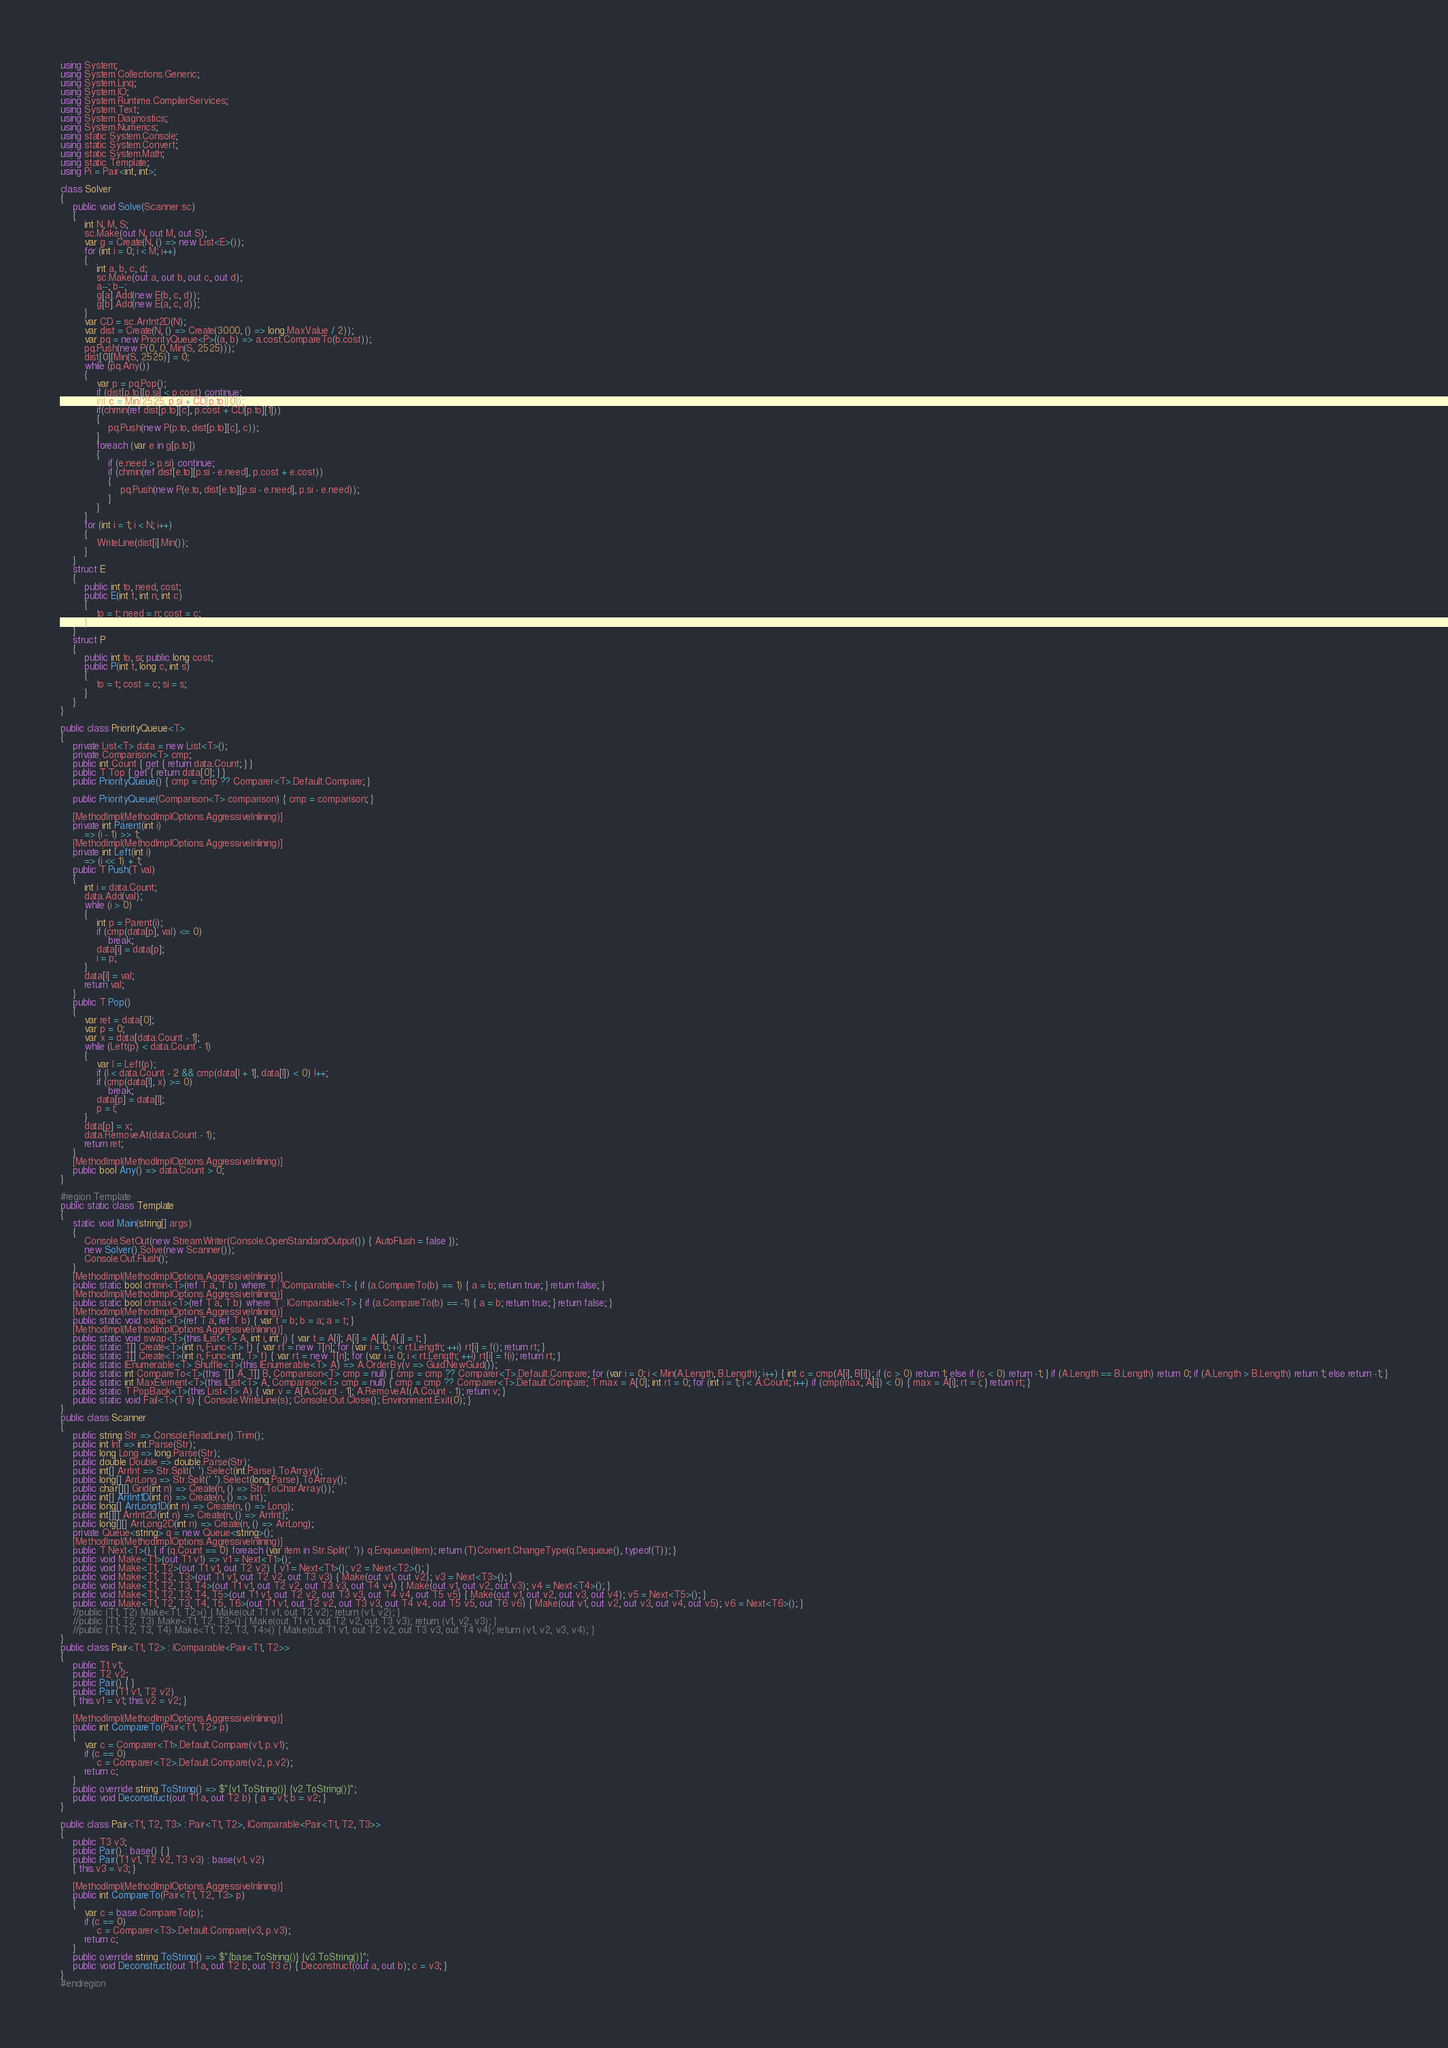<code> <loc_0><loc_0><loc_500><loc_500><_C#_>using System;
using System.Collections.Generic;
using System.Linq;
using System.IO;
using System.Runtime.CompilerServices;
using System.Text;
using System.Diagnostics;
using System.Numerics;
using static System.Console;
using static System.Convert;
using static System.Math;
using static Template;
using Pi = Pair<int, int>;

class Solver
{
    public void Solve(Scanner sc)
    {
        int N, M, S;
        sc.Make(out N, out M, out S);
        var g = Create(N, () => new List<E>());
        for (int i = 0; i < M; i++)
        {
            int a, b, c, d;
            sc.Make(out a, out b, out c, out d);
            a--; b--;
            g[a].Add(new E(b, c, d));
            g[b].Add(new E(a, c, d));
        }
        var CD = sc.ArrInt2D(N);
        var dist = Create(N, () => Create(3000, () => long.MaxValue / 2));
        var pq = new PriorityQueue<P>((a, b) => a.cost.CompareTo(b.cost));
        pq.Push(new P(0, 0, Min(S, 2525)));
        dist[0][Min(S, 2525)] = 0;
        while (pq.Any())
        {
            var p = pq.Pop();
            if (dist[p.to][p.si] < p.cost) continue;
            int c = Min(2525, p.si + CD[p.to][0]);
            if(chmin(ref dist[p.to][c], p.cost + CD[p.to][1]))
            {
                pq.Push(new P(p.to, dist[p.to][c], c));
            }
            foreach (var e in g[p.to])
            {
                if (e.need > p.si) continue;
                if (chmin(ref dist[e.to][p.si - e.need], p.cost + e.cost))
                {
                    pq.Push(new P(e.to, dist[e.to][p.si - e.need], p.si - e.need));
                }
            }
        }
        for (int i = 1; i < N; i++)
        {
            WriteLine(dist[i].Min());
        }
    }
    struct E
    {
        public int to, need, cost;
        public E(int t, int n, int c)
        {
            to = t; need = n; cost = c;
        }
    }
    struct P
    {
        public int to, si; public long cost;
        public P(int t, long c, int s)
        {
            to = t; cost = c; si = s;
        }
    }
}

public class PriorityQueue<T>
{
    private List<T> data = new List<T>();
    private Comparison<T> cmp;
    public int Count { get { return data.Count; } }
    public T Top { get { return data[0]; } }
    public PriorityQueue() { cmp = cmp ?? Comparer<T>.Default.Compare; }

    public PriorityQueue(Comparison<T> comparison) { cmp = comparison; }

    [MethodImpl(MethodImplOptions.AggressiveInlining)]
    private int Parent(int i)
        => (i - 1) >> 1;
    [MethodImpl(MethodImplOptions.AggressiveInlining)]
    private int Left(int i)
        => (i << 1) + 1;
    public T Push(T val)
    {
        int i = data.Count;
        data.Add(val);
        while (i > 0)
        {
            int p = Parent(i);
            if (cmp(data[p], val) <= 0)
                break;
            data[i] = data[p];
            i = p;
        }
        data[i] = val;
        return val;
    }
    public T Pop()
    {
        var ret = data[0];
        var p = 0;
        var x = data[data.Count - 1];
        while (Left(p) < data.Count - 1)
        {
            var l = Left(p);
            if (l < data.Count - 2 && cmp(data[l + 1], data[l]) < 0) l++;
            if (cmp(data[l], x) >= 0)
                break;
            data[p] = data[l];
            p = l;
        }
        data[p] = x;
        data.RemoveAt(data.Count - 1);
        return ret;
    }
    [MethodImpl(MethodImplOptions.AggressiveInlining)]
    public bool Any() => data.Count > 0;
}

#region Template
public static class Template
{
    static void Main(string[] args)
    {
        Console.SetOut(new StreamWriter(Console.OpenStandardOutput()) { AutoFlush = false });
        new Solver().Solve(new Scanner());
        Console.Out.Flush();
    }
    [MethodImpl(MethodImplOptions.AggressiveInlining)]
    public static bool chmin<T>(ref T a, T b) where T : IComparable<T> { if (a.CompareTo(b) == 1) { a = b; return true; } return false; }
    [MethodImpl(MethodImplOptions.AggressiveInlining)]
    public static bool chmax<T>(ref T a, T b) where T : IComparable<T> { if (a.CompareTo(b) == -1) { a = b; return true; } return false; }
    [MethodImpl(MethodImplOptions.AggressiveInlining)]
    public static void swap<T>(ref T a, ref T b) { var t = b; b = a; a = t; }
    [MethodImpl(MethodImplOptions.AggressiveInlining)]
    public static void swap<T>(this IList<T> A, int i, int j) { var t = A[i]; A[i] = A[j]; A[j] = t; }
    public static T[] Create<T>(int n, Func<T> f) { var rt = new T[n]; for (var i = 0; i < rt.Length; ++i) rt[i] = f(); return rt; }
    public static T[] Create<T>(int n, Func<int, T> f) { var rt = new T[n]; for (var i = 0; i < rt.Length; ++i) rt[i] = f(i); return rt; }
    public static IEnumerable<T> Shuffle<T>(this IEnumerable<T> A) => A.OrderBy(v => Guid.NewGuid());
    public static int CompareTo<T>(this T[] A, T[] B, Comparison<T> cmp = null) { cmp = cmp ?? Comparer<T>.Default.Compare; for (var i = 0; i < Min(A.Length, B.Length); i++) { int c = cmp(A[i], B[i]); if (c > 0) return 1; else if (c < 0) return -1; } if (A.Length == B.Length) return 0; if (A.Length > B.Length) return 1; else return -1; }
    public static int MaxElement<T>(this IList<T> A, Comparison<T> cmp = null) { cmp = cmp ?? Comparer<T>.Default.Compare; T max = A[0]; int rt = 0; for (int i = 1; i < A.Count; i++) if (cmp(max, A[i]) < 0) { max = A[i]; rt = i; } return rt; }
    public static T PopBack<T>(this List<T> A) { var v = A[A.Count - 1]; A.RemoveAt(A.Count - 1); return v; }
    public static void Fail<T>(T s) { Console.WriteLine(s); Console.Out.Close(); Environment.Exit(0); }
}
public class Scanner
{
    public string Str => Console.ReadLine().Trim();
    public int Int => int.Parse(Str);
    public long Long => long.Parse(Str);
    public double Double => double.Parse(Str);
    public int[] ArrInt => Str.Split(' ').Select(int.Parse).ToArray();
    public long[] ArrLong => Str.Split(' ').Select(long.Parse).ToArray();
    public char[][] Grid(int n) => Create(n, () => Str.ToCharArray());
    public int[] ArrInt1D(int n) => Create(n, () => Int);
    public long[] ArrLong1D(int n) => Create(n, () => Long);
    public int[][] ArrInt2D(int n) => Create(n, () => ArrInt);
    public long[][] ArrLong2D(int n) => Create(n, () => ArrLong);
    private Queue<string> q = new Queue<string>();
    [MethodImpl(MethodImplOptions.AggressiveInlining)]
    public T Next<T>() { if (q.Count == 0) foreach (var item in Str.Split(' ')) q.Enqueue(item); return (T)Convert.ChangeType(q.Dequeue(), typeof(T)); }
    public void Make<T1>(out T1 v1) => v1 = Next<T1>();
    public void Make<T1, T2>(out T1 v1, out T2 v2) { v1 = Next<T1>(); v2 = Next<T2>(); }
    public void Make<T1, T2, T3>(out T1 v1, out T2 v2, out T3 v3) { Make(out v1, out v2); v3 = Next<T3>(); }
    public void Make<T1, T2, T3, T4>(out T1 v1, out T2 v2, out T3 v3, out T4 v4) { Make(out v1, out v2, out v3); v4 = Next<T4>(); }
    public void Make<T1, T2, T3, T4, T5>(out T1 v1, out T2 v2, out T3 v3, out T4 v4, out T5 v5) { Make(out v1, out v2, out v3, out v4); v5 = Next<T5>(); }
    public void Make<T1, T2, T3, T4, T5, T6>(out T1 v1, out T2 v2, out T3 v3, out T4 v4, out T5 v5, out T6 v6) { Make(out v1, out v2, out v3, out v4, out v5); v6 = Next<T6>(); }
    //public (T1, T2) Make<T1, T2>() { Make(out T1 v1, out T2 v2); return (v1, v2); }
    //public (T1, T2, T3) Make<T1, T2, T3>() { Make(out T1 v1, out T2 v2, out T3 v3); return (v1, v2, v3); }
    //public (T1, T2, T3, T4) Make<T1, T2, T3, T4>() { Make(out T1 v1, out T2 v2, out T3 v3, out T4 v4); return (v1, v2, v3, v4); }
}
public class Pair<T1, T2> : IComparable<Pair<T1, T2>>
{
    public T1 v1;
    public T2 v2;
    public Pair() { }
    public Pair(T1 v1, T2 v2)
    { this.v1 = v1; this.v2 = v2; }

    [MethodImpl(MethodImplOptions.AggressiveInlining)]
    public int CompareTo(Pair<T1, T2> p)
    {
        var c = Comparer<T1>.Default.Compare(v1, p.v1);
        if (c == 0)
            c = Comparer<T2>.Default.Compare(v2, p.v2);
        return c;
    }
    public override string ToString() => $"{v1.ToString()} {v2.ToString()}";
    public void Deconstruct(out T1 a, out T2 b) { a = v1; b = v2; }
}

public class Pair<T1, T2, T3> : Pair<T1, T2>, IComparable<Pair<T1, T2, T3>>
{
    public T3 v3;
    public Pair() : base() { }
    public Pair(T1 v1, T2 v2, T3 v3) : base(v1, v2)
    { this.v3 = v3; }

    [MethodImpl(MethodImplOptions.AggressiveInlining)]
    public int CompareTo(Pair<T1, T2, T3> p)
    {
        var c = base.CompareTo(p);
        if (c == 0)
            c = Comparer<T3>.Default.Compare(v3, p.v3);
        return c;
    }
    public override string ToString() => $"{base.ToString()} {v3.ToString()}";
    public void Deconstruct(out T1 a, out T2 b, out T3 c) { Deconstruct(out a, out b); c = v3; }
}
#endregion
</code> 